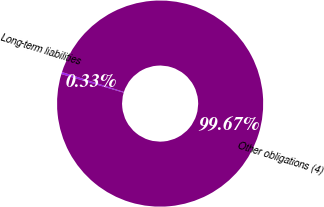Convert chart. <chart><loc_0><loc_0><loc_500><loc_500><pie_chart><fcel>Long-term liabilities<fcel>Other obligations (4)<nl><fcel>0.33%<fcel>99.67%<nl></chart> 